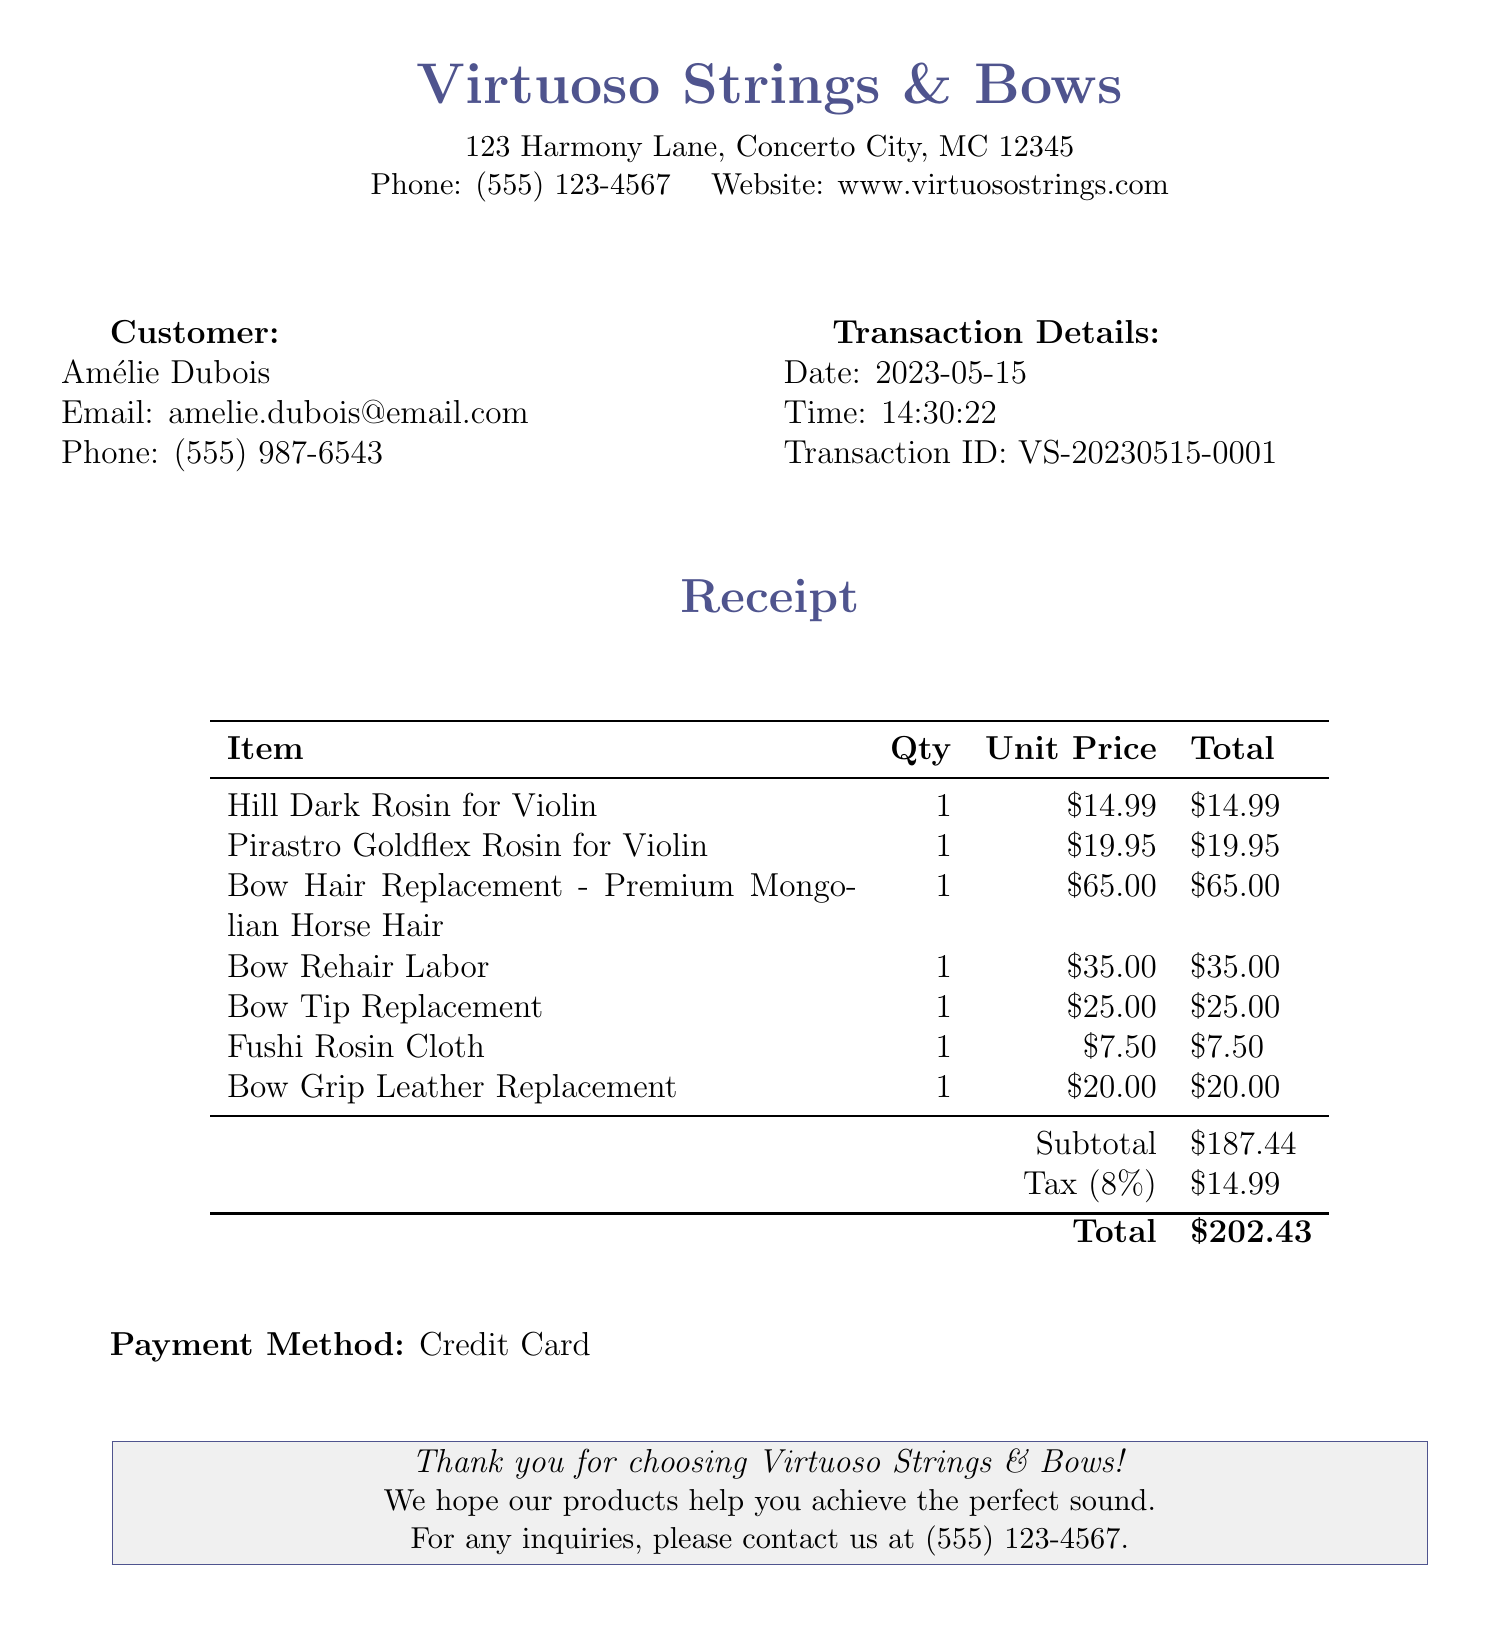What is the name of the store? The name of the store is listed in the document under store information.
Answer: Virtuoso Strings & Bows What items were purchased? The items purchased are detailed in the receipt items section of the document.
Answer: Hill Dark Rosin for Violin, Pirastro Goldflex Rosin for Violin, Bow Hair Replacement - Premium Mongolian Horse Hair, Bow Rehair Labor, Bow Tip Replacement, Fushi Rosin Cloth, Bow Grip Leather Replacement What is the total amount charged? The total amount charged is specified at the end of the receipt.
Answer: $202.43 What is the transaction date? The transaction date is provided in the transaction details section.
Answer: 2023-05-15 What was the unit price of the Bow Hair Replacement? The unit price of the Bow Hair Replacement is shown in the itemized list of the receipt.
Answer: $65.00 How much tax was applied to the transaction? The tax amount is calculated and presented separately in the receipt.
Answer: $14.99 What is the phone number of the store? The store's phone number is included in the store information section.
Answer: (555) 123-4567 What payment method was used? The payment method is indicated in the payment section of the receipt.
Answer: Credit Card 